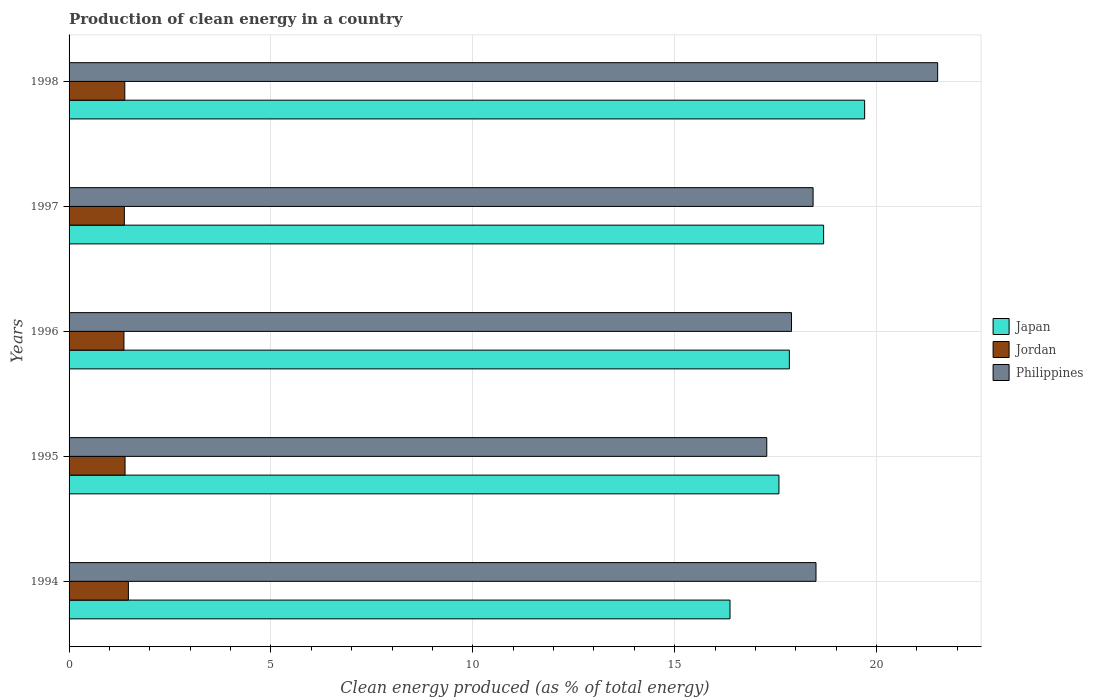How many different coloured bars are there?
Your response must be concise. 3. Are the number of bars per tick equal to the number of legend labels?
Give a very brief answer. Yes. What is the label of the 3rd group of bars from the top?
Provide a short and direct response. 1996. What is the percentage of clean energy produced in Philippines in 1995?
Your answer should be compact. 17.28. Across all years, what is the maximum percentage of clean energy produced in Philippines?
Provide a short and direct response. 21.51. Across all years, what is the minimum percentage of clean energy produced in Japan?
Offer a very short reply. 16.37. What is the total percentage of clean energy produced in Japan in the graph?
Provide a succinct answer. 90.19. What is the difference between the percentage of clean energy produced in Jordan in 1996 and that in 1998?
Your answer should be compact. -0.02. What is the difference between the percentage of clean energy produced in Japan in 1994 and the percentage of clean energy produced in Philippines in 1997?
Your answer should be compact. -2.06. What is the average percentage of clean energy produced in Philippines per year?
Make the answer very short. 18.72. In the year 1996, what is the difference between the percentage of clean energy produced in Jordan and percentage of clean energy produced in Japan?
Ensure brevity in your answer.  -16.48. In how many years, is the percentage of clean energy produced in Philippines greater than 9 %?
Keep it short and to the point. 5. What is the ratio of the percentage of clean energy produced in Japan in 1994 to that in 1997?
Your answer should be very brief. 0.88. Is the percentage of clean energy produced in Philippines in 1995 less than that in 1998?
Provide a short and direct response. Yes. What is the difference between the highest and the second highest percentage of clean energy produced in Jordan?
Your answer should be very brief. 0.08. What is the difference between the highest and the lowest percentage of clean energy produced in Philippines?
Offer a very short reply. 4.23. In how many years, is the percentage of clean energy produced in Japan greater than the average percentage of clean energy produced in Japan taken over all years?
Offer a very short reply. 2. Is the sum of the percentage of clean energy produced in Japan in 1994 and 1997 greater than the maximum percentage of clean energy produced in Jordan across all years?
Make the answer very short. Yes. What does the 2nd bar from the bottom in 1998 represents?
Offer a terse response. Jordan. Is it the case that in every year, the sum of the percentage of clean energy produced in Jordan and percentage of clean energy produced in Japan is greater than the percentage of clean energy produced in Philippines?
Your response must be concise. No. How many bars are there?
Ensure brevity in your answer.  15. Are the values on the major ticks of X-axis written in scientific E-notation?
Provide a succinct answer. No. What is the title of the graph?
Your answer should be very brief. Production of clean energy in a country. Does "Turkmenistan" appear as one of the legend labels in the graph?
Your answer should be compact. No. What is the label or title of the X-axis?
Give a very brief answer. Clean energy produced (as % of total energy). What is the Clean energy produced (as % of total energy) in Japan in 1994?
Provide a short and direct response. 16.37. What is the Clean energy produced (as % of total energy) of Jordan in 1994?
Provide a succinct answer. 1.47. What is the Clean energy produced (as % of total energy) in Philippines in 1994?
Your answer should be very brief. 18.5. What is the Clean energy produced (as % of total energy) in Japan in 1995?
Your answer should be compact. 17.58. What is the Clean energy produced (as % of total energy) in Jordan in 1995?
Give a very brief answer. 1.39. What is the Clean energy produced (as % of total energy) in Philippines in 1995?
Offer a terse response. 17.28. What is the Clean energy produced (as % of total energy) in Japan in 1996?
Make the answer very short. 17.84. What is the Clean energy produced (as % of total energy) in Jordan in 1996?
Provide a succinct answer. 1.36. What is the Clean energy produced (as % of total energy) of Philippines in 1996?
Give a very brief answer. 17.89. What is the Clean energy produced (as % of total energy) in Japan in 1997?
Offer a terse response. 18.69. What is the Clean energy produced (as % of total energy) in Jordan in 1997?
Offer a very short reply. 1.37. What is the Clean energy produced (as % of total energy) in Philippines in 1997?
Offer a very short reply. 18.43. What is the Clean energy produced (as % of total energy) of Japan in 1998?
Ensure brevity in your answer.  19.7. What is the Clean energy produced (as % of total energy) in Jordan in 1998?
Keep it short and to the point. 1.38. What is the Clean energy produced (as % of total energy) of Philippines in 1998?
Make the answer very short. 21.51. Across all years, what is the maximum Clean energy produced (as % of total energy) in Japan?
Provide a short and direct response. 19.7. Across all years, what is the maximum Clean energy produced (as % of total energy) of Jordan?
Your response must be concise. 1.47. Across all years, what is the maximum Clean energy produced (as % of total energy) of Philippines?
Keep it short and to the point. 21.51. Across all years, what is the minimum Clean energy produced (as % of total energy) in Japan?
Provide a short and direct response. 16.37. Across all years, what is the minimum Clean energy produced (as % of total energy) of Jordan?
Offer a very short reply. 1.36. Across all years, what is the minimum Clean energy produced (as % of total energy) in Philippines?
Provide a short and direct response. 17.28. What is the total Clean energy produced (as % of total energy) of Japan in the graph?
Your answer should be compact. 90.19. What is the total Clean energy produced (as % of total energy) of Jordan in the graph?
Provide a succinct answer. 6.96. What is the total Clean energy produced (as % of total energy) of Philippines in the graph?
Give a very brief answer. 93.62. What is the difference between the Clean energy produced (as % of total energy) in Japan in 1994 and that in 1995?
Offer a terse response. -1.21. What is the difference between the Clean energy produced (as % of total energy) of Jordan in 1994 and that in 1995?
Keep it short and to the point. 0.08. What is the difference between the Clean energy produced (as % of total energy) of Philippines in 1994 and that in 1995?
Your response must be concise. 1.22. What is the difference between the Clean energy produced (as % of total energy) of Japan in 1994 and that in 1996?
Offer a very short reply. -1.47. What is the difference between the Clean energy produced (as % of total energy) of Jordan in 1994 and that in 1996?
Your response must be concise. 0.11. What is the difference between the Clean energy produced (as % of total energy) of Philippines in 1994 and that in 1996?
Provide a short and direct response. 0.61. What is the difference between the Clean energy produced (as % of total energy) in Japan in 1994 and that in 1997?
Offer a very short reply. -2.32. What is the difference between the Clean energy produced (as % of total energy) in Jordan in 1994 and that in 1997?
Offer a very short reply. 0.1. What is the difference between the Clean energy produced (as % of total energy) in Philippines in 1994 and that in 1997?
Keep it short and to the point. 0.07. What is the difference between the Clean energy produced (as % of total energy) in Japan in 1994 and that in 1998?
Provide a succinct answer. -3.33. What is the difference between the Clean energy produced (as % of total energy) of Jordan in 1994 and that in 1998?
Your response must be concise. 0.09. What is the difference between the Clean energy produced (as % of total energy) of Philippines in 1994 and that in 1998?
Provide a short and direct response. -3.01. What is the difference between the Clean energy produced (as % of total energy) in Japan in 1995 and that in 1996?
Make the answer very short. -0.26. What is the difference between the Clean energy produced (as % of total energy) in Jordan in 1995 and that in 1996?
Give a very brief answer. 0.03. What is the difference between the Clean energy produced (as % of total energy) of Philippines in 1995 and that in 1996?
Your answer should be very brief. -0.61. What is the difference between the Clean energy produced (as % of total energy) in Japan in 1995 and that in 1997?
Provide a succinct answer. -1.11. What is the difference between the Clean energy produced (as % of total energy) of Jordan in 1995 and that in 1997?
Make the answer very short. 0.02. What is the difference between the Clean energy produced (as % of total energy) in Philippines in 1995 and that in 1997?
Your answer should be compact. -1.15. What is the difference between the Clean energy produced (as % of total energy) of Japan in 1995 and that in 1998?
Make the answer very short. -2.12. What is the difference between the Clean energy produced (as % of total energy) of Jordan in 1995 and that in 1998?
Offer a terse response. 0.01. What is the difference between the Clean energy produced (as % of total energy) of Philippines in 1995 and that in 1998?
Offer a terse response. -4.23. What is the difference between the Clean energy produced (as % of total energy) in Japan in 1996 and that in 1997?
Provide a short and direct response. -0.85. What is the difference between the Clean energy produced (as % of total energy) in Jordan in 1996 and that in 1997?
Make the answer very short. -0.01. What is the difference between the Clean energy produced (as % of total energy) of Philippines in 1996 and that in 1997?
Your answer should be very brief. -0.53. What is the difference between the Clean energy produced (as % of total energy) of Japan in 1996 and that in 1998?
Offer a terse response. -1.86. What is the difference between the Clean energy produced (as % of total energy) in Jordan in 1996 and that in 1998?
Keep it short and to the point. -0.02. What is the difference between the Clean energy produced (as % of total energy) in Philippines in 1996 and that in 1998?
Provide a short and direct response. -3.62. What is the difference between the Clean energy produced (as % of total energy) in Japan in 1997 and that in 1998?
Keep it short and to the point. -1.02. What is the difference between the Clean energy produced (as % of total energy) in Jordan in 1997 and that in 1998?
Your answer should be very brief. -0.01. What is the difference between the Clean energy produced (as % of total energy) of Philippines in 1997 and that in 1998?
Offer a terse response. -3.09. What is the difference between the Clean energy produced (as % of total energy) in Japan in 1994 and the Clean energy produced (as % of total energy) in Jordan in 1995?
Provide a short and direct response. 14.98. What is the difference between the Clean energy produced (as % of total energy) of Japan in 1994 and the Clean energy produced (as % of total energy) of Philippines in 1995?
Keep it short and to the point. -0.91. What is the difference between the Clean energy produced (as % of total energy) of Jordan in 1994 and the Clean energy produced (as % of total energy) of Philippines in 1995?
Your answer should be very brief. -15.81. What is the difference between the Clean energy produced (as % of total energy) of Japan in 1994 and the Clean energy produced (as % of total energy) of Jordan in 1996?
Keep it short and to the point. 15.01. What is the difference between the Clean energy produced (as % of total energy) of Japan in 1994 and the Clean energy produced (as % of total energy) of Philippines in 1996?
Your answer should be very brief. -1.52. What is the difference between the Clean energy produced (as % of total energy) of Jordan in 1994 and the Clean energy produced (as % of total energy) of Philippines in 1996?
Offer a terse response. -16.42. What is the difference between the Clean energy produced (as % of total energy) of Japan in 1994 and the Clean energy produced (as % of total energy) of Jordan in 1997?
Make the answer very short. 15. What is the difference between the Clean energy produced (as % of total energy) of Japan in 1994 and the Clean energy produced (as % of total energy) of Philippines in 1997?
Offer a very short reply. -2.06. What is the difference between the Clean energy produced (as % of total energy) of Jordan in 1994 and the Clean energy produced (as % of total energy) of Philippines in 1997?
Offer a very short reply. -16.96. What is the difference between the Clean energy produced (as % of total energy) in Japan in 1994 and the Clean energy produced (as % of total energy) in Jordan in 1998?
Offer a very short reply. 14.99. What is the difference between the Clean energy produced (as % of total energy) in Japan in 1994 and the Clean energy produced (as % of total energy) in Philippines in 1998?
Your response must be concise. -5.14. What is the difference between the Clean energy produced (as % of total energy) in Jordan in 1994 and the Clean energy produced (as % of total energy) in Philippines in 1998?
Keep it short and to the point. -20.04. What is the difference between the Clean energy produced (as % of total energy) in Japan in 1995 and the Clean energy produced (as % of total energy) in Jordan in 1996?
Provide a succinct answer. 16.22. What is the difference between the Clean energy produced (as % of total energy) of Japan in 1995 and the Clean energy produced (as % of total energy) of Philippines in 1996?
Your answer should be very brief. -0.31. What is the difference between the Clean energy produced (as % of total energy) of Jordan in 1995 and the Clean energy produced (as % of total energy) of Philippines in 1996?
Your answer should be very brief. -16.51. What is the difference between the Clean energy produced (as % of total energy) of Japan in 1995 and the Clean energy produced (as % of total energy) of Jordan in 1997?
Make the answer very short. 16.21. What is the difference between the Clean energy produced (as % of total energy) of Japan in 1995 and the Clean energy produced (as % of total energy) of Philippines in 1997?
Give a very brief answer. -0.85. What is the difference between the Clean energy produced (as % of total energy) of Jordan in 1995 and the Clean energy produced (as % of total energy) of Philippines in 1997?
Your answer should be very brief. -17.04. What is the difference between the Clean energy produced (as % of total energy) of Japan in 1995 and the Clean energy produced (as % of total energy) of Jordan in 1998?
Offer a terse response. 16.2. What is the difference between the Clean energy produced (as % of total energy) in Japan in 1995 and the Clean energy produced (as % of total energy) in Philippines in 1998?
Your response must be concise. -3.93. What is the difference between the Clean energy produced (as % of total energy) of Jordan in 1995 and the Clean energy produced (as % of total energy) of Philippines in 1998?
Provide a short and direct response. -20.13. What is the difference between the Clean energy produced (as % of total energy) of Japan in 1996 and the Clean energy produced (as % of total energy) of Jordan in 1997?
Keep it short and to the point. 16.47. What is the difference between the Clean energy produced (as % of total energy) in Japan in 1996 and the Clean energy produced (as % of total energy) in Philippines in 1997?
Your response must be concise. -0.59. What is the difference between the Clean energy produced (as % of total energy) of Jordan in 1996 and the Clean energy produced (as % of total energy) of Philippines in 1997?
Your response must be concise. -17.07. What is the difference between the Clean energy produced (as % of total energy) in Japan in 1996 and the Clean energy produced (as % of total energy) in Jordan in 1998?
Keep it short and to the point. 16.46. What is the difference between the Clean energy produced (as % of total energy) of Japan in 1996 and the Clean energy produced (as % of total energy) of Philippines in 1998?
Ensure brevity in your answer.  -3.67. What is the difference between the Clean energy produced (as % of total energy) of Jordan in 1996 and the Clean energy produced (as % of total energy) of Philippines in 1998?
Ensure brevity in your answer.  -20.15. What is the difference between the Clean energy produced (as % of total energy) of Japan in 1997 and the Clean energy produced (as % of total energy) of Jordan in 1998?
Your answer should be compact. 17.31. What is the difference between the Clean energy produced (as % of total energy) of Japan in 1997 and the Clean energy produced (as % of total energy) of Philippines in 1998?
Your response must be concise. -2.82. What is the difference between the Clean energy produced (as % of total energy) in Jordan in 1997 and the Clean energy produced (as % of total energy) in Philippines in 1998?
Your response must be concise. -20.14. What is the average Clean energy produced (as % of total energy) in Japan per year?
Provide a succinct answer. 18.04. What is the average Clean energy produced (as % of total energy) in Jordan per year?
Keep it short and to the point. 1.39. What is the average Clean energy produced (as % of total energy) of Philippines per year?
Your answer should be very brief. 18.72. In the year 1994, what is the difference between the Clean energy produced (as % of total energy) of Japan and Clean energy produced (as % of total energy) of Jordan?
Your response must be concise. 14.9. In the year 1994, what is the difference between the Clean energy produced (as % of total energy) in Japan and Clean energy produced (as % of total energy) in Philippines?
Offer a very short reply. -2.13. In the year 1994, what is the difference between the Clean energy produced (as % of total energy) of Jordan and Clean energy produced (as % of total energy) of Philippines?
Keep it short and to the point. -17.03. In the year 1995, what is the difference between the Clean energy produced (as % of total energy) in Japan and Clean energy produced (as % of total energy) in Jordan?
Offer a very short reply. 16.2. In the year 1995, what is the difference between the Clean energy produced (as % of total energy) in Japan and Clean energy produced (as % of total energy) in Philippines?
Keep it short and to the point. 0.3. In the year 1995, what is the difference between the Clean energy produced (as % of total energy) in Jordan and Clean energy produced (as % of total energy) in Philippines?
Provide a short and direct response. -15.89. In the year 1996, what is the difference between the Clean energy produced (as % of total energy) in Japan and Clean energy produced (as % of total energy) in Jordan?
Provide a succinct answer. 16.48. In the year 1996, what is the difference between the Clean energy produced (as % of total energy) in Japan and Clean energy produced (as % of total energy) in Philippines?
Offer a very short reply. -0.05. In the year 1996, what is the difference between the Clean energy produced (as % of total energy) in Jordan and Clean energy produced (as % of total energy) in Philippines?
Your answer should be very brief. -16.53. In the year 1997, what is the difference between the Clean energy produced (as % of total energy) of Japan and Clean energy produced (as % of total energy) of Jordan?
Ensure brevity in your answer.  17.32. In the year 1997, what is the difference between the Clean energy produced (as % of total energy) of Japan and Clean energy produced (as % of total energy) of Philippines?
Provide a succinct answer. 0.26. In the year 1997, what is the difference between the Clean energy produced (as % of total energy) of Jordan and Clean energy produced (as % of total energy) of Philippines?
Your answer should be compact. -17.06. In the year 1998, what is the difference between the Clean energy produced (as % of total energy) of Japan and Clean energy produced (as % of total energy) of Jordan?
Your answer should be compact. 18.32. In the year 1998, what is the difference between the Clean energy produced (as % of total energy) in Japan and Clean energy produced (as % of total energy) in Philippines?
Your response must be concise. -1.81. In the year 1998, what is the difference between the Clean energy produced (as % of total energy) of Jordan and Clean energy produced (as % of total energy) of Philippines?
Your response must be concise. -20.13. What is the ratio of the Clean energy produced (as % of total energy) of Japan in 1994 to that in 1995?
Your answer should be very brief. 0.93. What is the ratio of the Clean energy produced (as % of total energy) in Jordan in 1994 to that in 1995?
Offer a very short reply. 1.06. What is the ratio of the Clean energy produced (as % of total energy) of Philippines in 1994 to that in 1995?
Offer a terse response. 1.07. What is the ratio of the Clean energy produced (as % of total energy) of Japan in 1994 to that in 1996?
Provide a short and direct response. 0.92. What is the ratio of the Clean energy produced (as % of total energy) of Jordan in 1994 to that in 1996?
Keep it short and to the point. 1.08. What is the ratio of the Clean energy produced (as % of total energy) in Philippines in 1994 to that in 1996?
Keep it short and to the point. 1.03. What is the ratio of the Clean energy produced (as % of total energy) of Japan in 1994 to that in 1997?
Ensure brevity in your answer.  0.88. What is the ratio of the Clean energy produced (as % of total energy) in Jordan in 1994 to that in 1997?
Provide a succinct answer. 1.07. What is the ratio of the Clean energy produced (as % of total energy) of Philippines in 1994 to that in 1997?
Provide a short and direct response. 1. What is the ratio of the Clean energy produced (as % of total energy) in Japan in 1994 to that in 1998?
Provide a short and direct response. 0.83. What is the ratio of the Clean energy produced (as % of total energy) in Jordan in 1994 to that in 1998?
Provide a succinct answer. 1.06. What is the ratio of the Clean energy produced (as % of total energy) in Philippines in 1994 to that in 1998?
Your response must be concise. 0.86. What is the ratio of the Clean energy produced (as % of total energy) of Japan in 1995 to that in 1996?
Offer a very short reply. 0.99. What is the ratio of the Clean energy produced (as % of total energy) in Jordan in 1995 to that in 1996?
Provide a short and direct response. 1.02. What is the ratio of the Clean energy produced (as % of total energy) in Philippines in 1995 to that in 1996?
Provide a short and direct response. 0.97. What is the ratio of the Clean energy produced (as % of total energy) of Japan in 1995 to that in 1997?
Your answer should be compact. 0.94. What is the ratio of the Clean energy produced (as % of total energy) of Jordan in 1995 to that in 1997?
Provide a short and direct response. 1.01. What is the ratio of the Clean energy produced (as % of total energy) of Philippines in 1995 to that in 1997?
Offer a very short reply. 0.94. What is the ratio of the Clean energy produced (as % of total energy) in Japan in 1995 to that in 1998?
Your answer should be very brief. 0.89. What is the ratio of the Clean energy produced (as % of total energy) in Jordan in 1995 to that in 1998?
Your response must be concise. 1. What is the ratio of the Clean energy produced (as % of total energy) of Philippines in 1995 to that in 1998?
Keep it short and to the point. 0.8. What is the ratio of the Clean energy produced (as % of total energy) of Japan in 1996 to that in 1997?
Provide a succinct answer. 0.95. What is the ratio of the Clean energy produced (as % of total energy) in Japan in 1996 to that in 1998?
Give a very brief answer. 0.91. What is the ratio of the Clean energy produced (as % of total energy) of Jordan in 1996 to that in 1998?
Provide a short and direct response. 0.98. What is the ratio of the Clean energy produced (as % of total energy) of Philippines in 1996 to that in 1998?
Your response must be concise. 0.83. What is the ratio of the Clean energy produced (as % of total energy) of Japan in 1997 to that in 1998?
Provide a short and direct response. 0.95. What is the ratio of the Clean energy produced (as % of total energy) of Jordan in 1997 to that in 1998?
Provide a succinct answer. 0.99. What is the ratio of the Clean energy produced (as % of total energy) of Philippines in 1997 to that in 1998?
Your answer should be compact. 0.86. What is the difference between the highest and the second highest Clean energy produced (as % of total energy) of Japan?
Provide a succinct answer. 1.02. What is the difference between the highest and the second highest Clean energy produced (as % of total energy) in Jordan?
Offer a terse response. 0.08. What is the difference between the highest and the second highest Clean energy produced (as % of total energy) in Philippines?
Ensure brevity in your answer.  3.01. What is the difference between the highest and the lowest Clean energy produced (as % of total energy) of Japan?
Your response must be concise. 3.33. What is the difference between the highest and the lowest Clean energy produced (as % of total energy) of Jordan?
Keep it short and to the point. 0.11. What is the difference between the highest and the lowest Clean energy produced (as % of total energy) in Philippines?
Your answer should be compact. 4.23. 